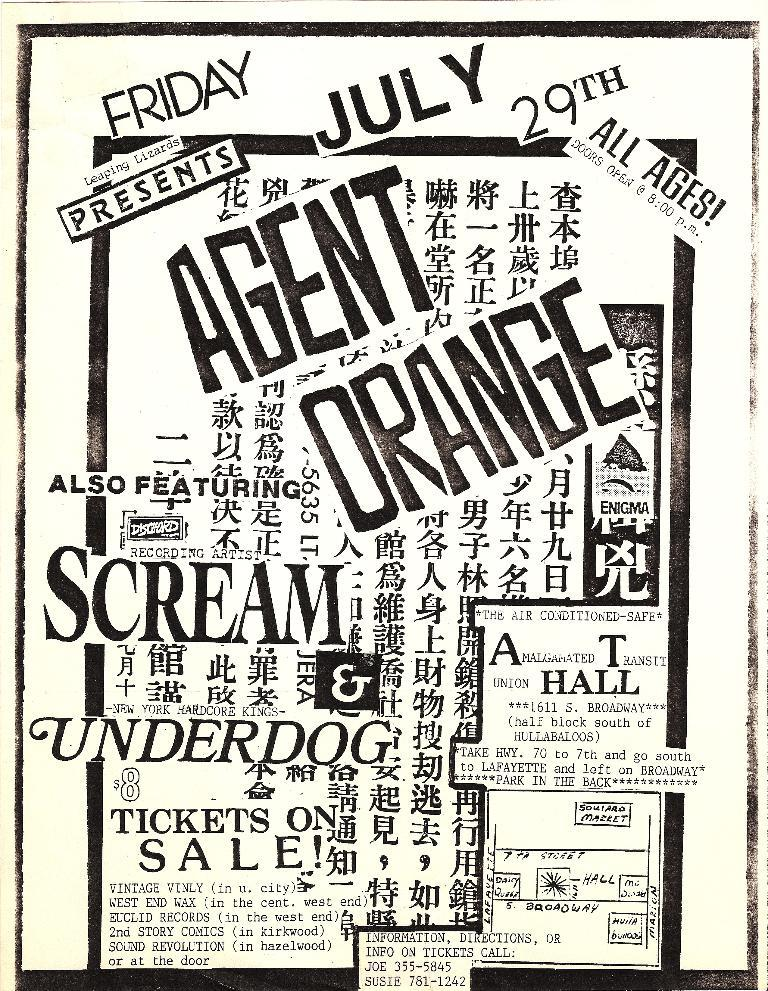Provide a one-sentence caption for the provided image. A flyer for an event has many different languages on it. 